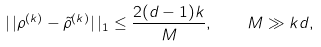Convert formula to latex. <formula><loc_0><loc_0><loc_500><loc_500>| \, | \rho ^ { ( k ) } - \tilde { \rho } ^ { ( k ) } | \, | _ { 1 } \leq \frac { 2 ( d - 1 ) k } M , \quad M \gg k d ,</formula> 